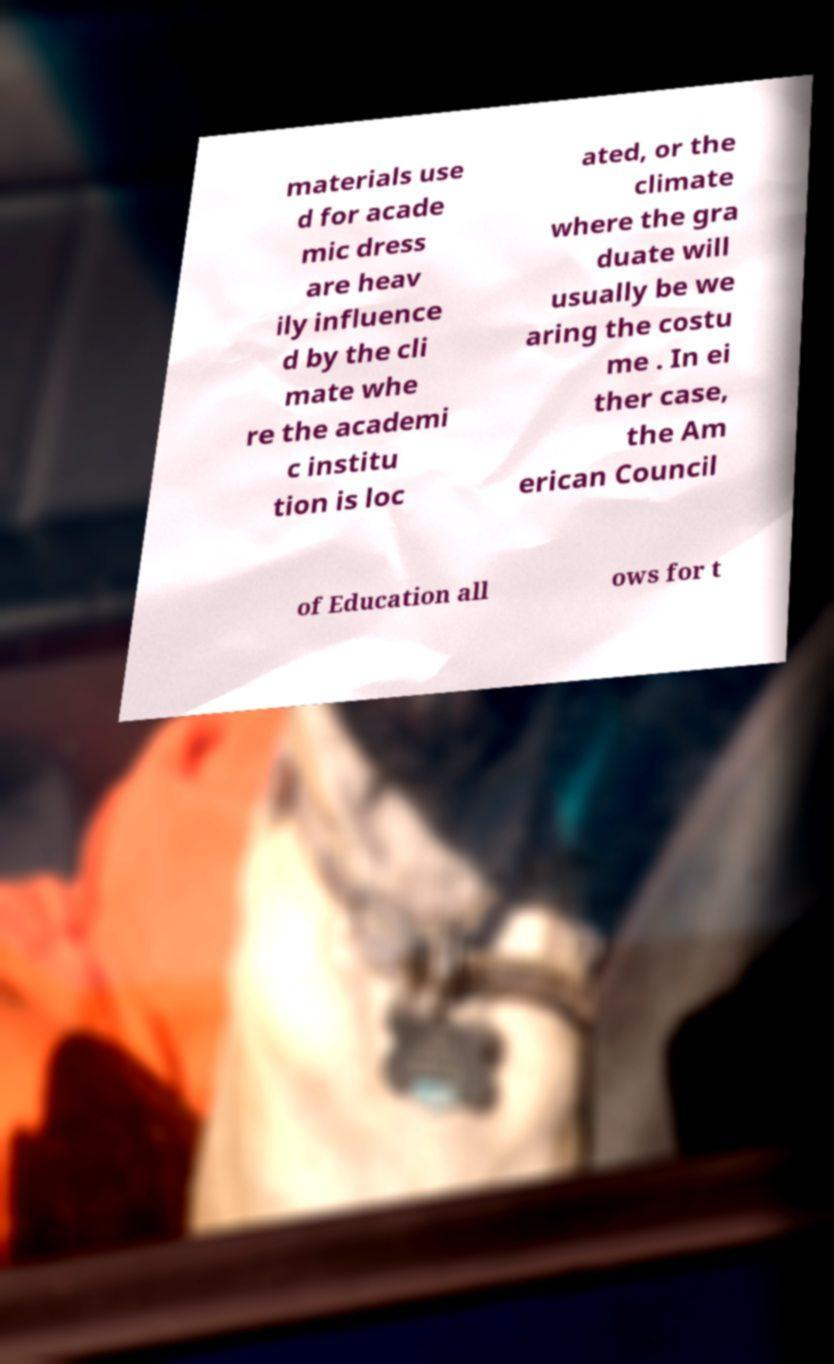What messages or text are displayed in this image? I need them in a readable, typed format. materials use d for acade mic dress are heav ily influence d by the cli mate whe re the academi c institu tion is loc ated, or the climate where the gra duate will usually be we aring the costu me . In ei ther case, the Am erican Council of Education all ows for t 